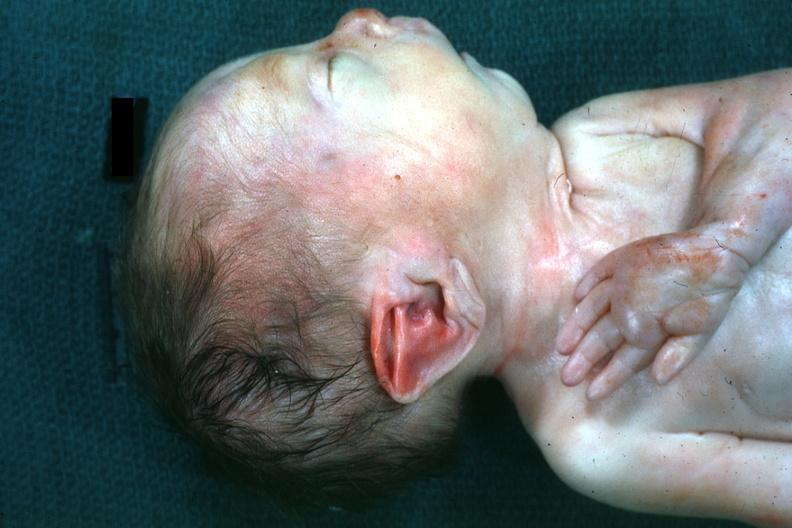what is present?
Answer the question using a single word or phrase. Potters facies 